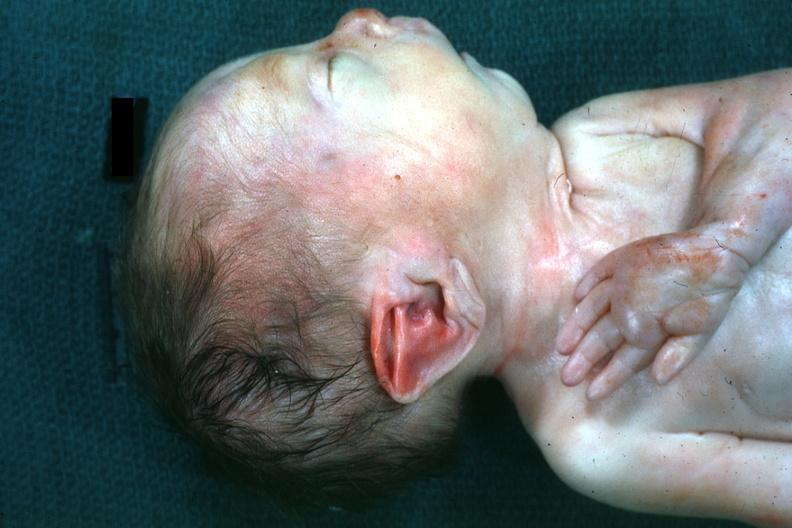what is present?
Answer the question using a single word or phrase. Potters facies 